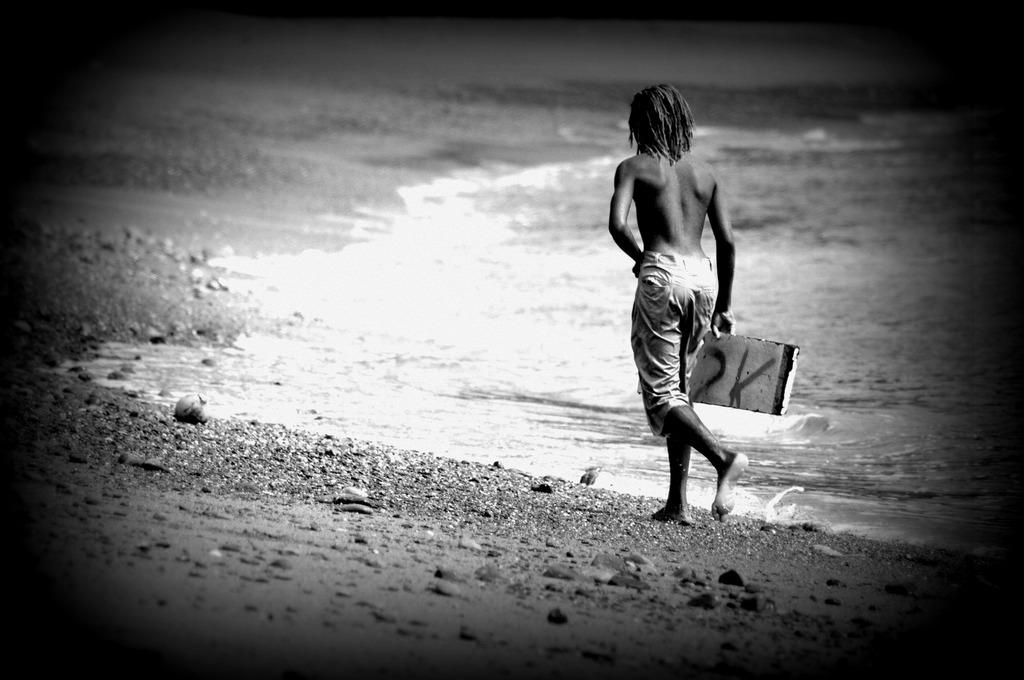What is the color scheme of the image? The image is black and white. Can you describe the main subject in the image? There is a person in the image. What is the person doing in the image? The person is walking on the side of a beach. What is the person wearing in the image? The person is not wearing a shirt. How many rings can be seen on the person's fingers in the image? There are no rings visible on the person's fingers in the image, as the image is black and white and the person is not wearing a shirt. What phase of the moon is visible in the image? The image is black and white and does not depict the moon, so it is not possible to determine the phase of the moon. 